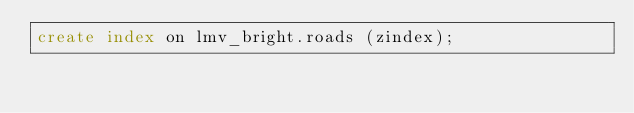Convert code to text. <code><loc_0><loc_0><loc_500><loc_500><_SQL_>create index on lmv_bright.roads (zindex);
</code> 